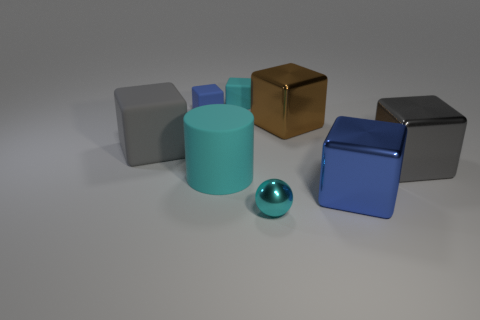Subtract all small blue cubes. How many cubes are left? 5 Subtract all gray cubes. How many cubes are left? 4 Subtract all cubes. How many objects are left? 2 Add 2 small red cubes. How many objects exist? 10 Subtract all purple spheres. Subtract all yellow cylinders. How many spheres are left? 1 Subtract all purple balls. How many gray blocks are left? 2 Subtract all cubes. Subtract all gray blocks. How many objects are left? 0 Add 4 blue matte blocks. How many blue matte blocks are left? 5 Add 4 gray rubber things. How many gray rubber things exist? 5 Subtract 0 brown cylinders. How many objects are left? 8 